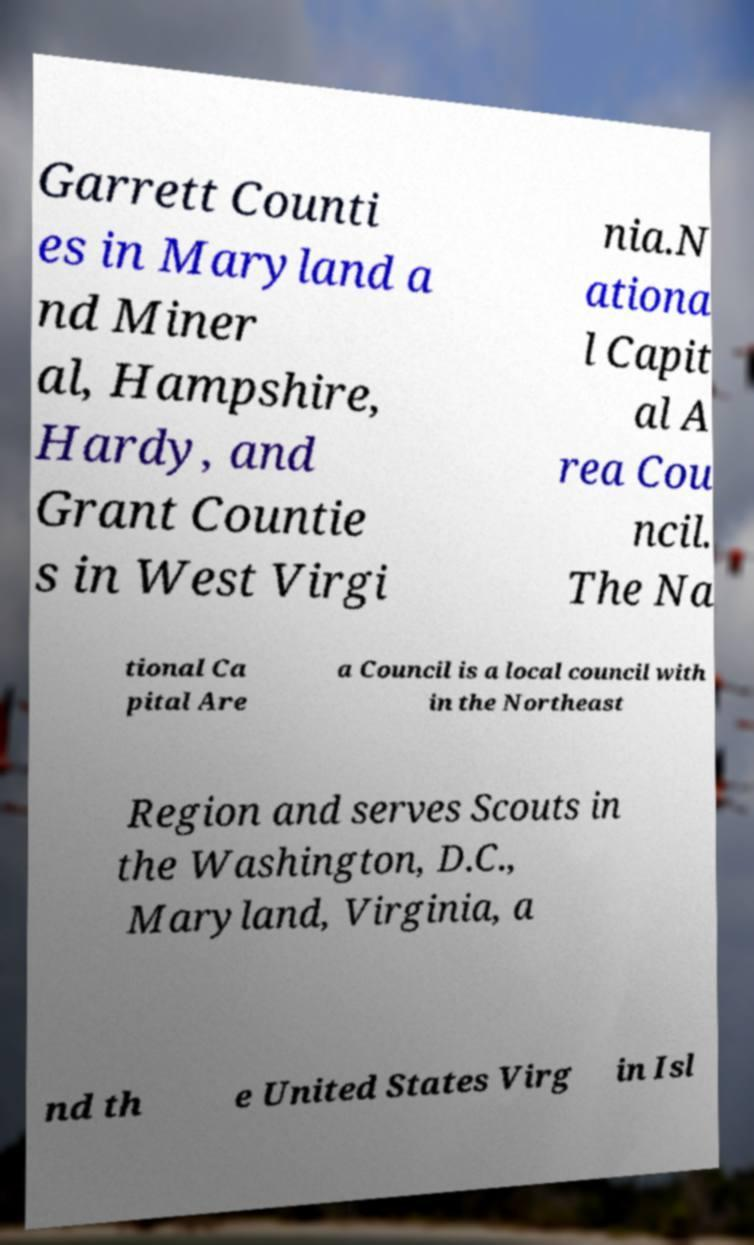Could you extract and type out the text from this image? Garrett Counti es in Maryland a nd Miner al, Hampshire, Hardy, and Grant Countie s in West Virgi nia.N ationa l Capit al A rea Cou ncil. The Na tional Ca pital Are a Council is a local council with in the Northeast Region and serves Scouts in the Washington, D.C., Maryland, Virginia, a nd th e United States Virg in Isl 